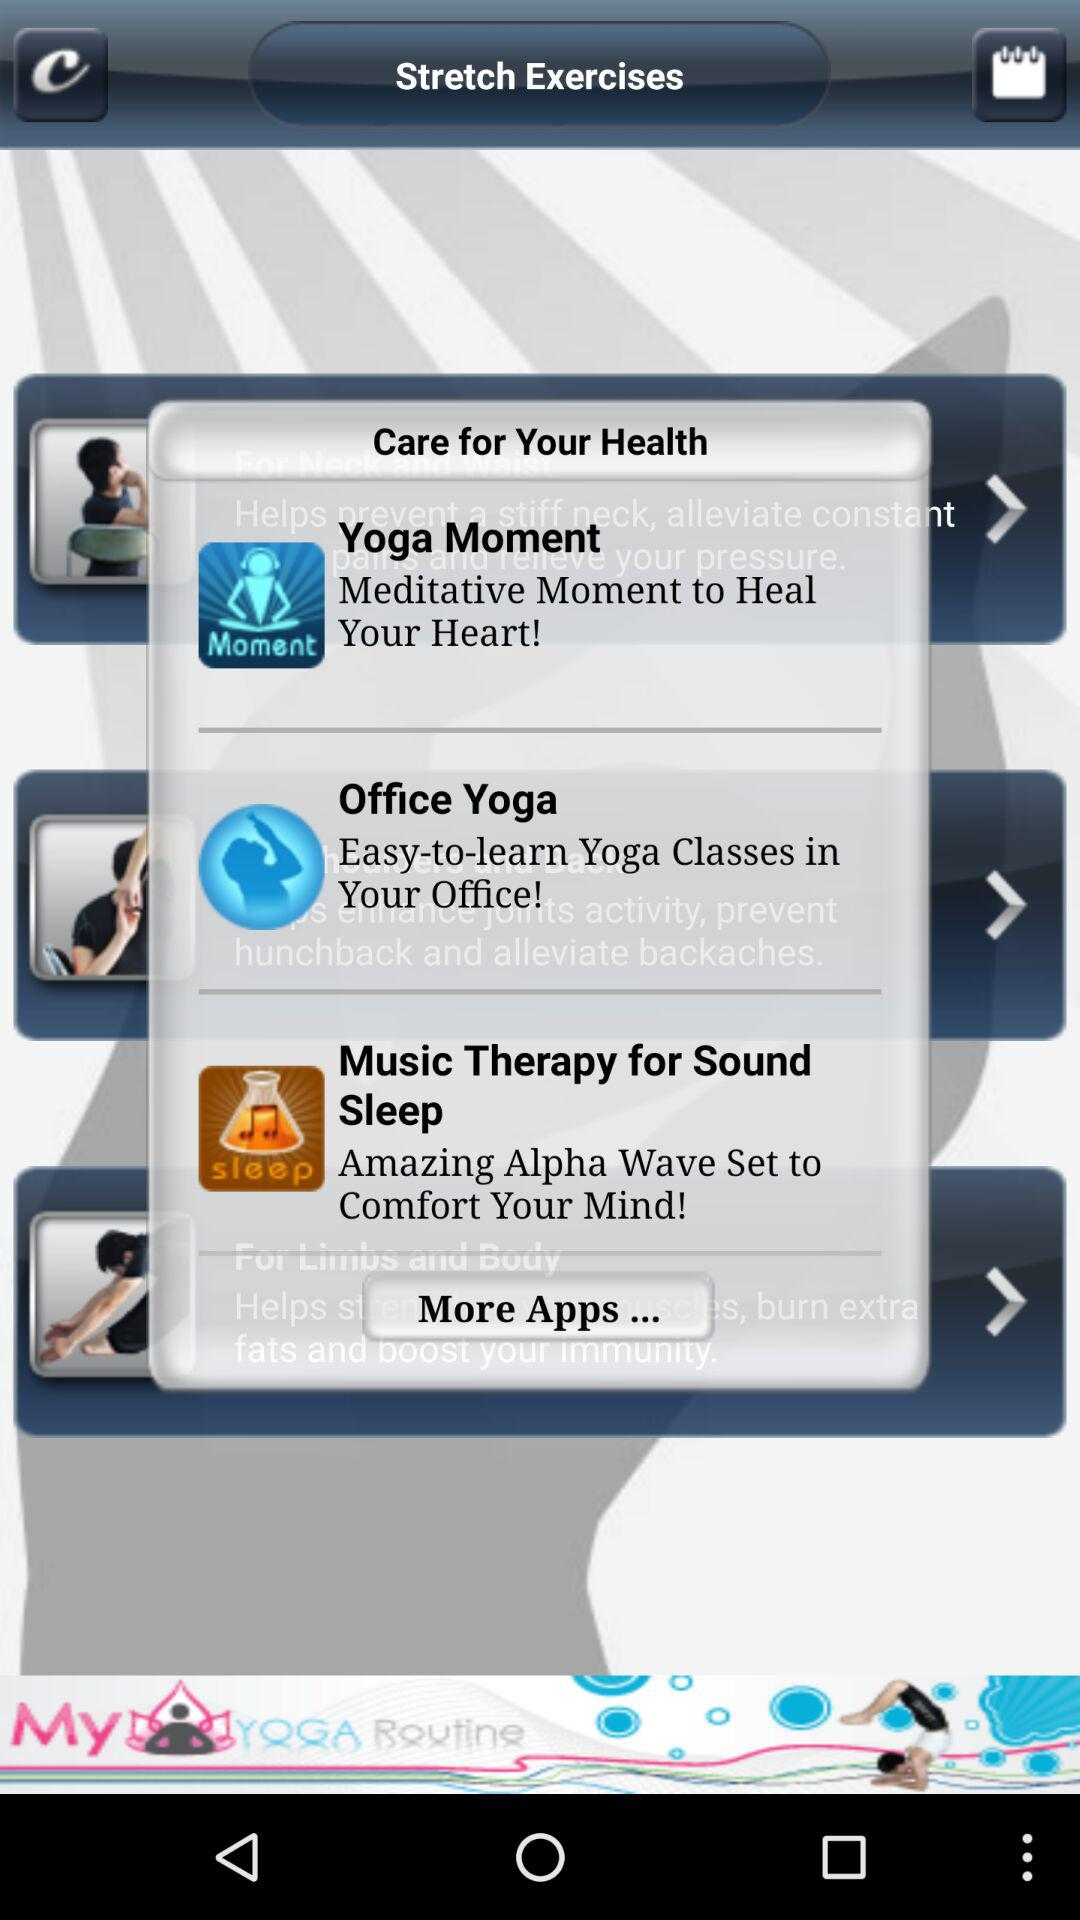How many moves does "Office Yoga" teach us?
When the provided information is insufficient, respond with <no answer>. <no answer> 